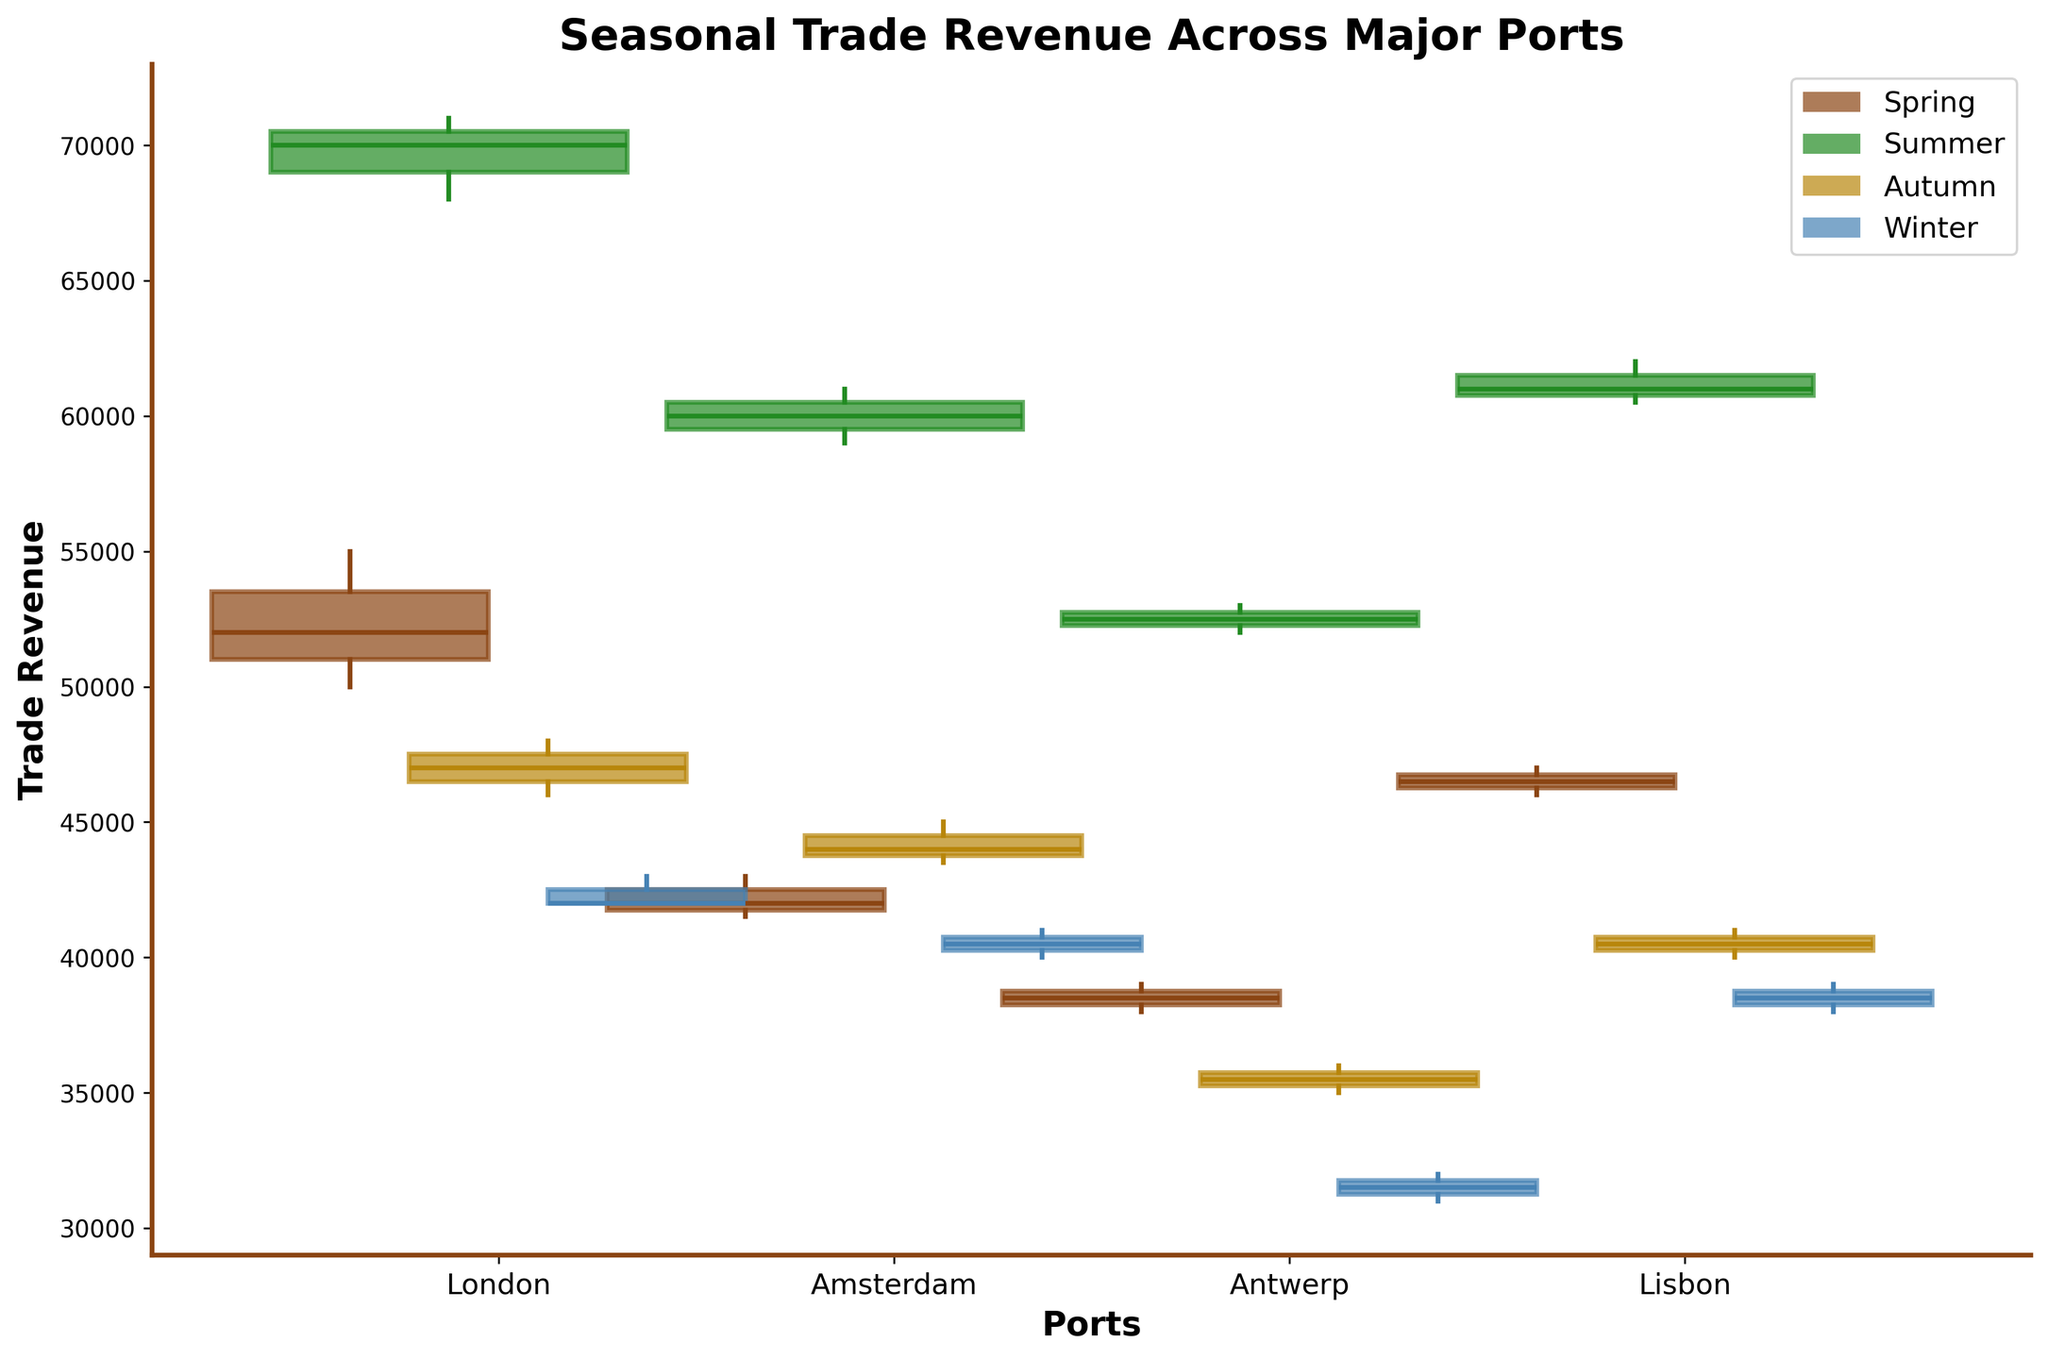Which port has the highest trade revenue in summer? By looking at the box plot for the summer season, identify the port with the highest median line. The highest median in the summer season is for London.
Answer: London What is the trend of trade revenue for Amsterdam across the seasons? Examine the position of the box plots for Amsterdam across all seasons. The median values are highest in the summer, followed by spring, autumn, and then winter. This indicates a decreasing trend from summer to winter.
Answer: Decreasing Which season demonstrates the widest variation in trade revenue for London? By comparing the width of the boxes for each season for London, the summer season has the widest box, indicating the highest range of trade revenue.
Answer: Summer In which season does Lisbon have the lowest trade revenue? By looking at the box plots for Lisbon across the seasons, identify the season where the median line is the lowest. The lowest median is seen in winter.
Answer: Winter Is the median trade revenue for Antwerp higher in spring or autumn? Compare the median lines of the box plots of Antwerp for spring and autumn. The spring median is higher than the autumn median.
Answer: Spring How does the trade revenue variation in winter compare between Amsterdam and Antwerp? Compare the width of the boxes for Amsterdam and Antwerp in winter. The width for Antwerp is narrower than for Amsterdam, indicating less variation.
Answer: Less variation in Antwerp Are there any ports where the median trade revenue is consistently higher across all seasons? Check the median lines for each port across all seasons. London consistently has higher median trade revenues compared to Amsterdam, Antwerp, and Lisbon across all seasons.
Answer: London Which port shows the most significant drop in trade revenue from summer to autumn? Calculate the difference between the summer and autumn medians for each port and compare. London shows the most significant drop from summer to autumn.
Answer: London 